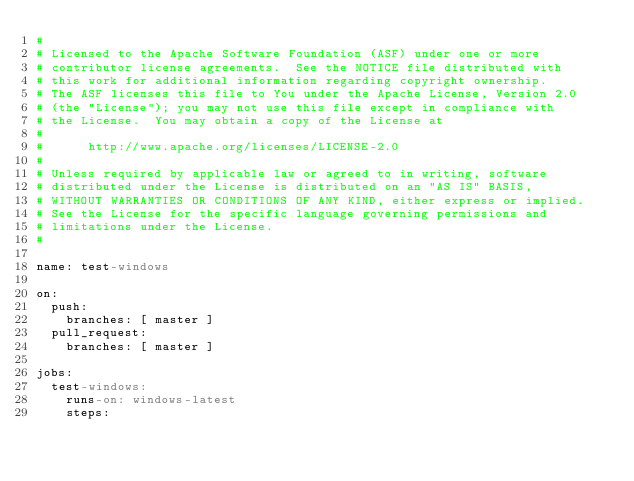<code> <loc_0><loc_0><loc_500><loc_500><_YAML_>#
# Licensed to the Apache Software Foundation (ASF) under one or more
# contributor license agreements.  See the NOTICE file distributed with
# this work for additional information regarding copyright ownership.
# The ASF licenses this file to You under the Apache License, Version 2.0
# (the "License"); you may not use this file except in compliance with
# the License.  You may obtain a copy of the License at
#
#      http://www.apache.org/licenses/LICENSE-2.0
#
# Unless required by applicable law or agreed to in writing, software
# distributed under the License is distributed on an "AS IS" BASIS,
# WITHOUT WARRANTIES OR CONDITIONS OF ANY KIND, either express or implied.
# See the License for the specific language governing permissions and
# limitations under the License.
#

name: test-windows

on:
  push:
    branches: [ master ]
  pull_request:
    branches: [ master ]

jobs:
  test-windows:
    runs-on: windows-latest
    steps:</code> 